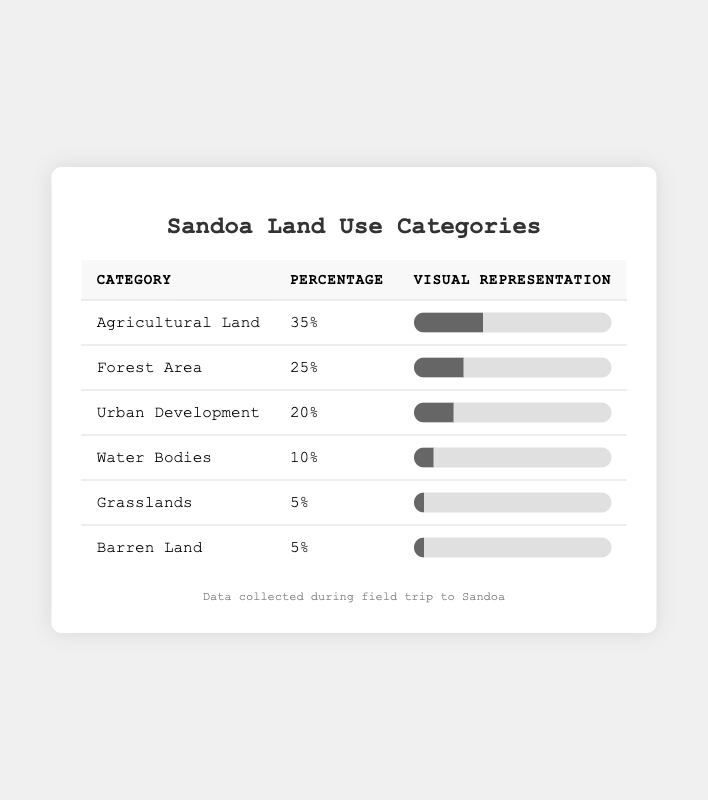What is the percentage of Agricultural Land in Sandoa? The table shows that the percentage of Agricultural Land is listed next to the corresponding category. In this case, it states that Agricultural Land accounts for 35%.
Answer: 35% Which land use category occupies the least percentage of land in Sandoa? By looking at the percentages listed, Grasslands and Barren Land each occupy 5%, which is the lowest percentage among all the categories.
Answer: Grasslands and Barren Land What is the total percentage of Forest Area and Water Bodies combined? To find the total percentage, you add the percentage of Forest Area (25%) to that of Water Bodies (10%). So, 25% + 10% = 35%.
Answer: 35% Is Urban Development more than 15% of the land use in Sandoa? The table indicates that Urban Development is at 20%. Since 20% is greater than 15%, the answer is true.
Answer: Yes What percentage of Sandoa's land is either Agricultural Land or Forest Area? To find this, you add the percentages of Agricultural Land (35%) and Forest Area (25%). Therefore, 35% + 25% = 60%.
Answer: 60% How much more percentage does Agricultural Land occupy compared to Grasslands? Agricultural Land occupies 35% while Grasslands occupy 5%. The difference is calculated by subtracting Grasslands from Agricultural Land: 35% - 5% = 30%.
Answer: 30% If we combine the percentages of Urban Development and Water Bodies, do they surpass the percentage of Forest Area? First, we add Urban Development (20%) and Water Bodies (10%), which gives 20% + 10% = 30%. Then, we compare this with Forest Area, which is 25%. Since 30% is greater than 25%, they do surpass it.
Answer: Yes What is the ratio of Agricultural Land to Barren Land in percentage terms? The percentage of Agricultural Land is 35% and the percentage of Barren Land is 5%. To find the ratio, divide 35% by 5%, which equals 7. This means there are 7 parts Agricultural Land for every 1 part Barren Land.
Answer: 7:1 What land use category occupies 10% of the land, and how does that relate to the total land use percentages in the table? The table shows that Water Bodies occupy 10%. This percentage contributes to the overall land use percentages and is lower than Agricultural Land, Forest Area, and Urban Development, indicating it is a smaller segment of the land use categories.
Answer: Water Bodies Which two land use categories together make up half of Sandoa’s land use? By checking the values, Forest Area (25%) and Water Bodies (10%) together make 35%, and Agricultural Land on its own (35%) does not combine with them to make 50%. However, if we consider adding Agricultural Land (35%) with any other category (for example, Grasslands or Barren Land), we still fall short of half (50%). Therefore, the two categories that come closest and can be considered significant are the first two highest percentages, which summed do not equal 50%. Hence, interrelation may differ but they do not amount to exact half.
Answer: No two categories sum to half 